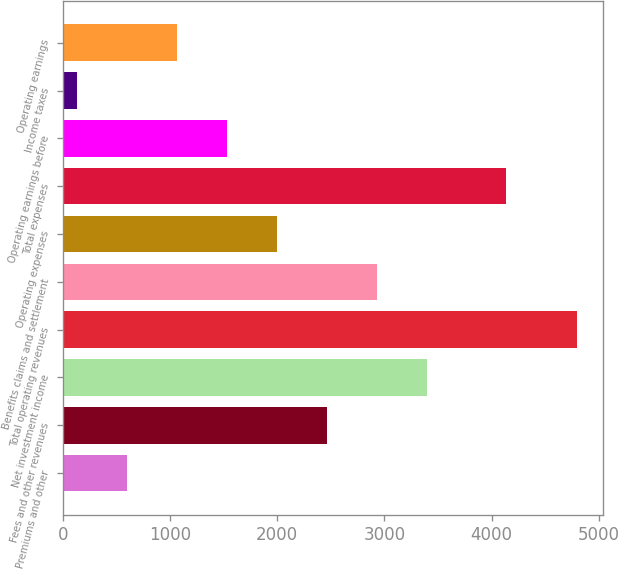Convert chart. <chart><loc_0><loc_0><loc_500><loc_500><bar_chart><fcel>Premiums and other<fcel>Fees and other revenues<fcel>Net investment income<fcel>Total operating revenues<fcel>Benefits claims and settlement<fcel>Operating expenses<fcel>Total expenses<fcel>Operating earnings before<fcel>Income taxes<fcel>Operating earnings<nl><fcel>604.22<fcel>2468.3<fcel>3400.34<fcel>4798.4<fcel>2934.32<fcel>2002.28<fcel>4128.9<fcel>1536.26<fcel>138.2<fcel>1070.24<nl></chart> 